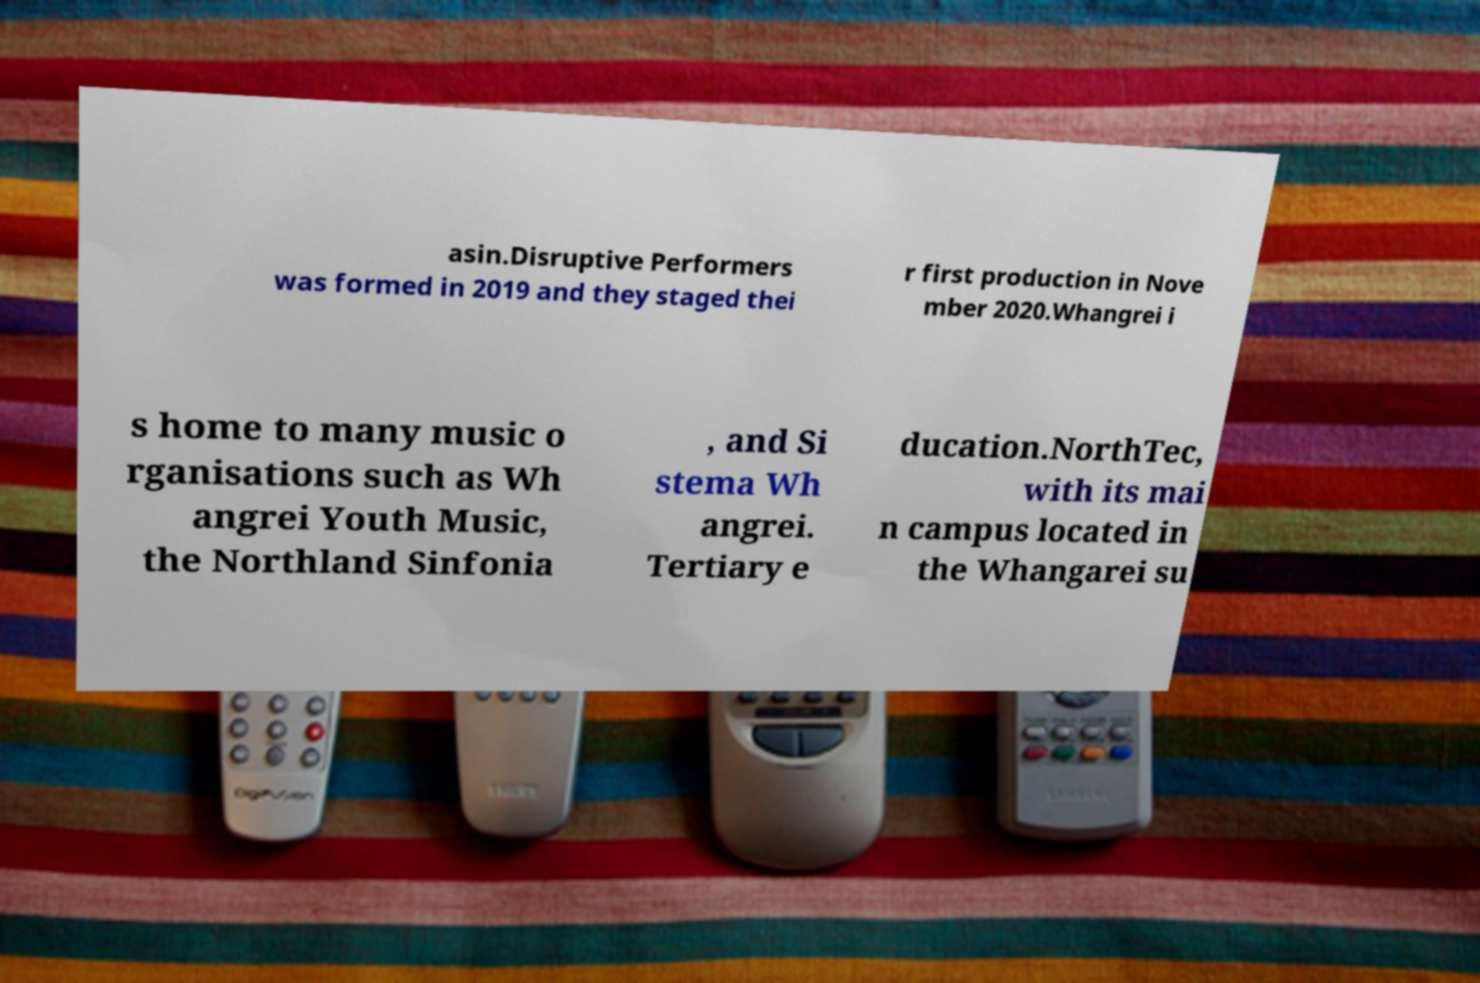Please identify and transcribe the text found in this image. asin.Disruptive Performers was formed in 2019 and they staged thei r first production in Nove mber 2020.Whangrei i s home to many music o rganisations such as Wh angrei Youth Music, the Northland Sinfonia , and Si stema Wh angrei. Tertiary e ducation.NorthTec, with its mai n campus located in the Whangarei su 